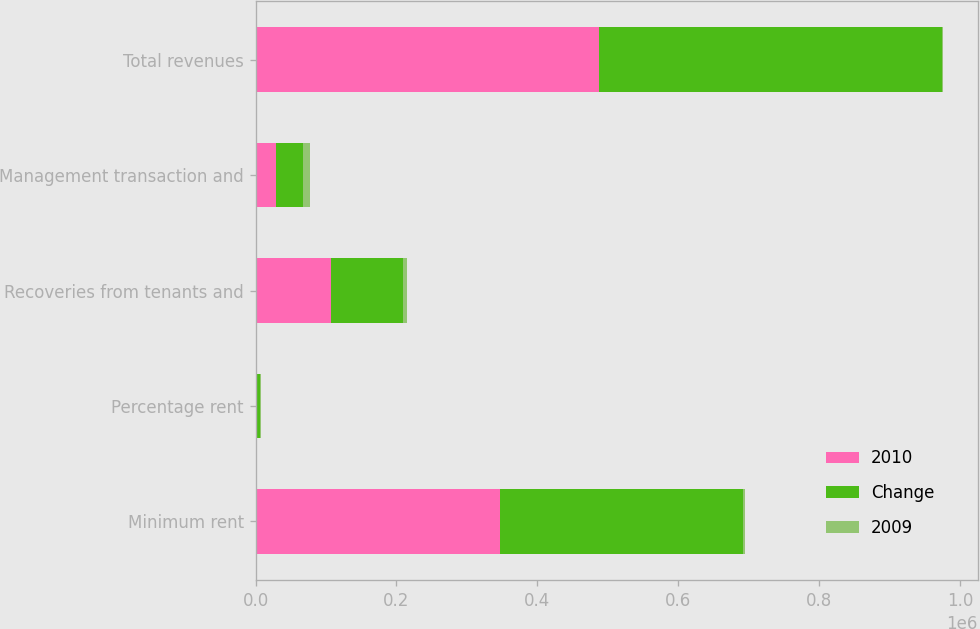<chart> <loc_0><loc_0><loc_500><loc_500><stacked_bar_chart><ecel><fcel>Minimum rent<fcel>Percentage rent<fcel>Recoveries from tenants and<fcel>Management transaction and<fcel>Total revenues<nl><fcel>2010<fcel>347122<fcel>2540<fcel>107744<fcel>29400<fcel>486806<nl><fcel>Change<fcel>344709<fcel>3585<fcel>101490<fcel>38289<fcel>488073<nl><fcel>2009<fcel>2413<fcel>1045<fcel>6254<fcel>8889<fcel>1267<nl></chart> 